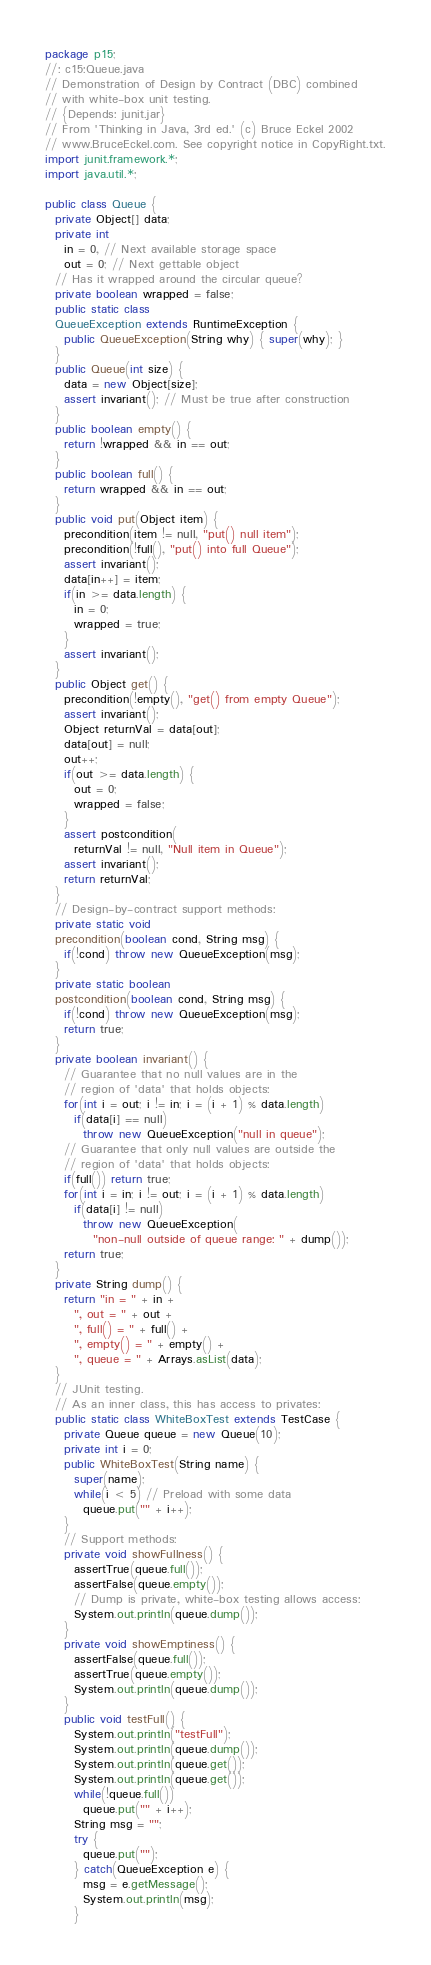Convert code to text. <code><loc_0><loc_0><loc_500><loc_500><_Java_>package p15;
//: c15:Queue.java
// Demonstration of Design by Contract (DBC) combined
// with white-box unit testing.
// {Depends: junit.jar}
// From 'Thinking in Java, 3rd ed.' (c) Bruce Eckel 2002
// www.BruceEckel.com. See copyright notice in CopyRight.txt.
import junit.framework.*;
import java.util.*;

public class Queue {
  private Object[] data;
  private int
    in = 0, // Next available storage space
    out = 0; // Next gettable object
  // Has it wrapped around the circular queue?
  private boolean wrapped = false;
  public static class
  QueueException extends RuntimeException {
    public QueueException(String why) { super(why); }
  }
  public Queue(int size) {
    data = new Object[size];
    assert invariant(); // Must be true after construction
  }
  public boolean empty() {
    return !wrapped && in == out;
  }
  public boolean full() {
    return wrapped && in == out;
  }
  public void put(Object item) {
    precondition(item != null, "put() null item");
    precondition(!full(), "put() into full Queue");
    assert invariant();
    data[in++] = item;
    if(in >= data.length) {
      in = 0;
      wrapped = true;
    }
    assert invariant();
  }
  public Object get() {
    precondition(!empty(), "get() from empty Queue");
    assert invariant();
    Object returnVal = data[out];
    data[out] = null;
    out++;
    if(out >= data.length) {
      out = 0;
      wrapped = false;
    }
    assert postcondition(
      returnVal != null, "Null item in Queue");
    assert invariant();
    return returnVal;
  }
  // Design-by-contract support methods:
  private static void
  precondition(boolean cond, String msg) {
    if(!cond) throw new QueueException(msg);
  }
  private static boolean
  postcondition(boolean cond, String msg) {
    if(!cond) throw new QueueException(msg);
    return true;
  }
  private boolean invariant() {
    // Guarantee that no null values are in the
    // region of 'data' that holds objects:
    for(int i = out; i != in; i = (i + 1) % data.length)
      if(data[i] == null)
        throw new QueueException("null in queue");
    // Guarantee that only null values are outside the
    // region of 'data' that holds objects:
    if(full()) return true;
    for(int i = in; i != out; i = (i + 1) % data.length)
      if(data[i] != null)
        throw new QueueException(
          "non-null outside of queue range: " + dump());
    return true;
  }
  private String dump() {
    return "in = " + in +
      ", out = " + out +
      ", full() = " + full() +
      ", empty() = " + empty() +
      ", queue = " + Arrays.asList(data);
  }
  // JUnit testing.
  // As an inner class, this has access to privates:
  public static class WhiteBoxTest extends TestCase {
    private Queue queue = new Queue(10);
    private int i = 0;
    public WhiteBoxTest(String name) {
      super(name);
      while(i < 5) // Preload with some data
        queue.put("" + i++);
    }
    // Support methods:
    private void showFullness() {
      assertTrue(queue.full());
      assertFalse(queue.empty());
      // Dump is private, white-box testing allows access:
      System.out.println(queue.dump());
    }
    private void showEmptiness() {
      assertFalse(queue.full());
      assertTrue(queue.empty());
      System.out.println(queue.dump());
    }
    public void testFull() {
      System.out.println("testFull");
      System.out.println(queue.dump());
      System.out.println(queue.get());
      System.out.println(queue.get());
      while(!queue.full())
        queue.put("" + i++);
      String msg = "";
      try {
        queue.put("");
      } catch(QueueException e) {
        msg = e.getMessage();
        System.out.println(msg);
      }</code> 